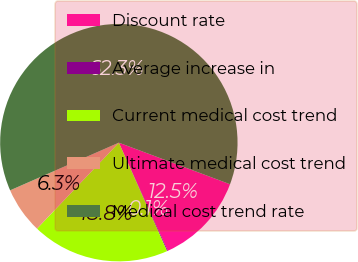Convert chart to OTSL. <chart><loc_0><loc_0><loc_500><loc_500><pie_chart><fcel>Discount rate<fcel>Average increase in<fcel>Current medical cost trend<fcel>Ultimate medical cost trend<fcel>Medical cost trend rate<nl><fcel>12.54%<fcel>0.11%<fcel>18.76%<fcel>6.32%<fcel>62.27%<nl></chart> 